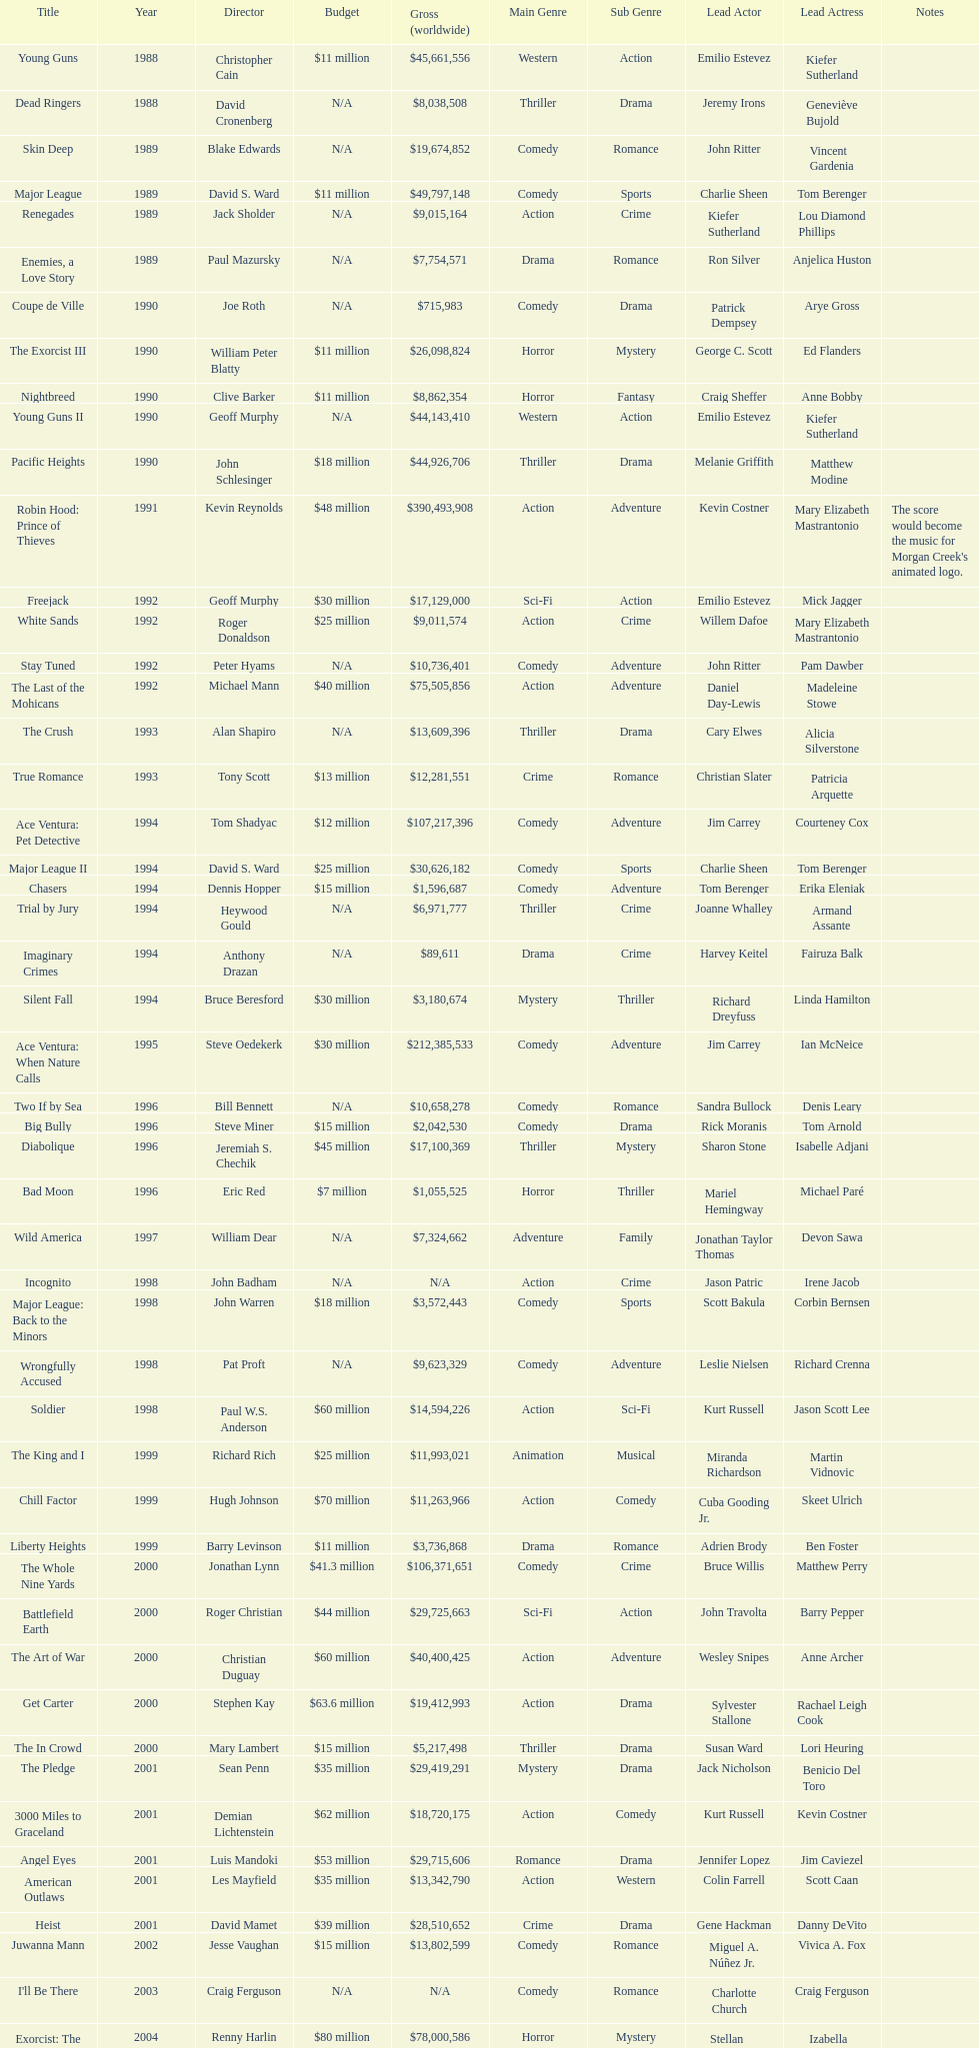What was the only movie with a 48 million dollar budget? Robin Hood: Prince of Thieves. 